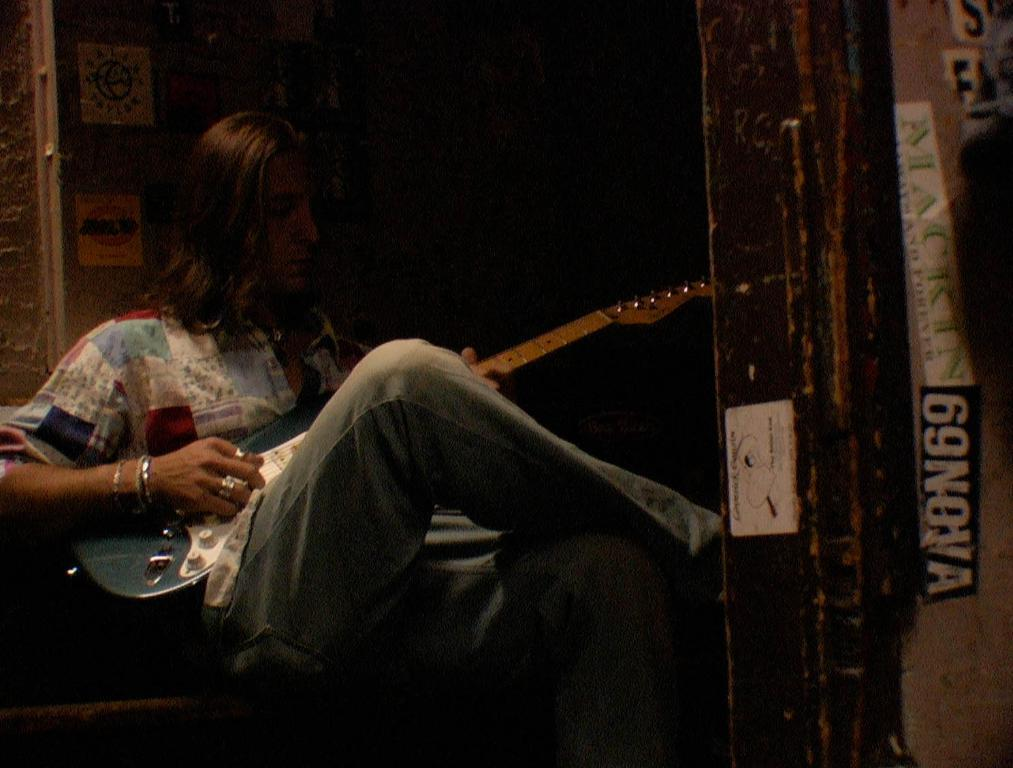<image>
Summarize the visual content of the image. A man playing a guitar next to a wall with a 69NOVA sticker on it. 